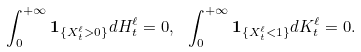Convert formula to latex. <formula><loc_0><loc_0><loc_500><loc_500>\int _ { 0 } ^ { + \infty } { \mathbf 1 } _ { \{ X ^ { \ell } _ { t } > 0 \} } d H _ { t } ^ { \ell } = 0 , \ \int _ { 0 } ^ { + \infty } { \mathbf 1 } _ { \{ X ^ { \ell } _ { t } < 1 \} } d K _ { t } ^ { \ell } = 0 .</formula> 